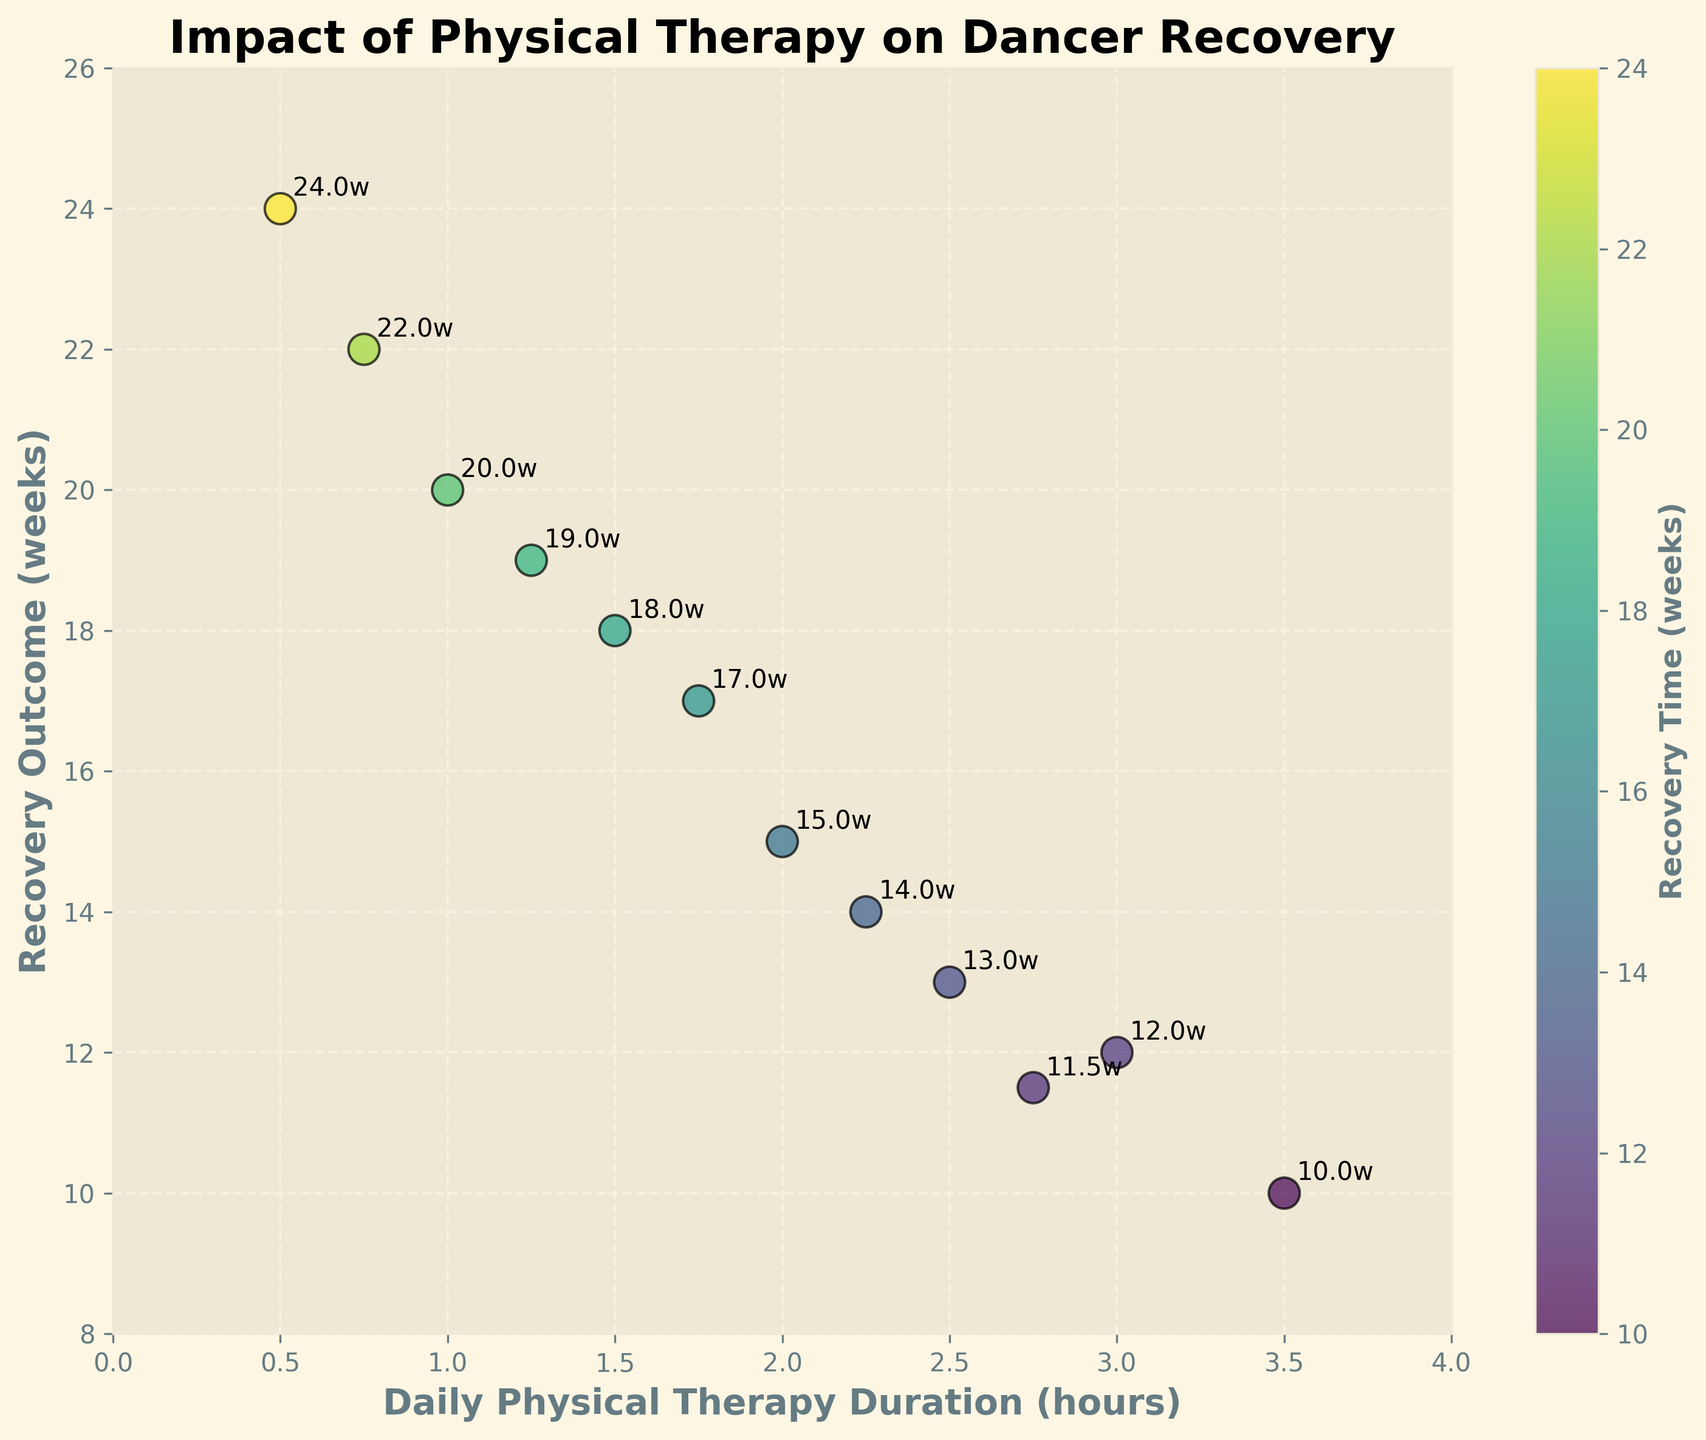What is the title of the plot? The title is usually located at the top of the plot. In this scatter plot, it is written as a statement which summarizes the main focus of the data.
Answer: Impact of Physical Therapy on Dancer Recovery What are the labels on the axes? The labels on the axes provide information about the data being represented. In this plot, the x-axis label represents the duration of daily physical therapy, while the y-axis label represents the recovery outcome.
Answer: Daily Physical Therapy Duration (hours) and Recovery Outcome (weeks) Can you count the number of data points in the scatter plot? By observing and counting the points where the markers are plotted on the scatter plot, we can determine the total number of data points.
Answer: 12 Which physical therapy duration has the fastest recovery outcome? The physical therapy duration with the fastest recovery outcome would be the one with the lowest value on the y-axis. By looking at the scatter plot, identify the marker with the smallest y-value.
Answer: 3.5 hours How is the recovery time related to the physical therapy duration visually in the scatter plot? By looking at the trend of the points from left to right, we see if they go up or down. In this plot, we see that as physical therapy duration increases, the recovery outcome generally decreases.
Answer: Negative correlation What is the recovery outcome for a physical therapy duration of 2.5 hours? Find the data point where the x-value is 2.5 and note the corresponding y-value, which represents the recovery outcome in weeks.
Answer: 13 weeks How does the recovery outcome of 1.5 hours physical therapy compare to that of 2.75 hours? To compare, find the y-values for both x-values (1.5 and 2.75 hours). The recovery outcomes are 18 weeks and 11.5 weeks, respectively. Thus, 2.75 hours has a faster recovery.
Answer: 2.75 hours results in a faster recovery What is the average recovery time for physical therapy durations of 1.0, 1.5, and 2.0 hours? Find the recovery outcomes for these durations: 20, 18, and 15 weeks. Sum these values (20 + 18 + 15 = 53) and divide by the number of data points (53 / 3).
Answer: 17.67 weeks Which point stands out or seems unusual in the scatter plot? Identify any point not following the general trend. If most points show a decrease in recovery time with increased therapy, an outlier would be one that doesn't align with this trend. There is no obvious outlier.
Answer: No obvious outlier Based on the scatter plot, what can be concluded about the effectiveness of increasing daily physical therapy duration on recovery outcomes? Observing the general trend of the scatter plot reveals the relationship between therapy duration and recovery outcome. As the therapy duration increases, the recovery time tends to decrease, indicating that longer daily physical therapy results in quicker recovery.
Answer: Longer daily physical therapy results in quicker recovery 